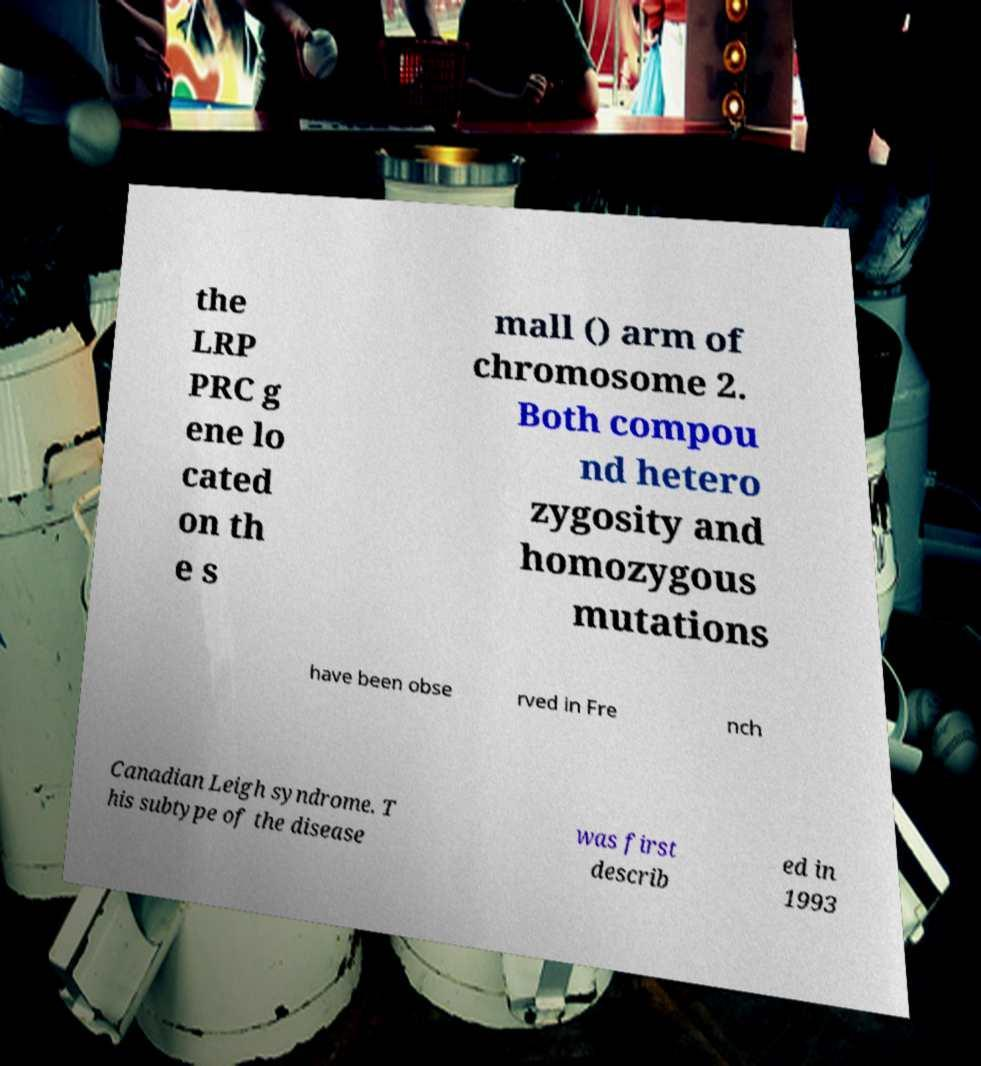Can you accurately transcribe the text from the provided image for me? the LRP PRC g ene lo cated on th e s mall () arm of chromosome 2. Both compou nd hetero zygosity and homozygous mutations have been obse rved in Fre nch Canadian Leigh syndrome. T his subtype of the disease was first describ ed in 1993 